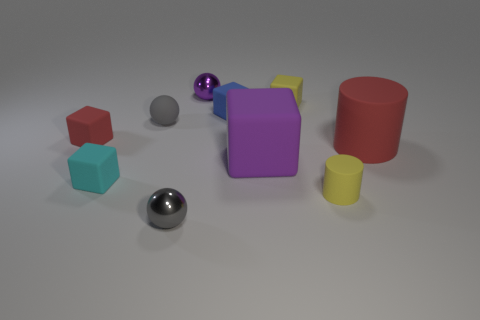The red thing that is on the left side of the gray rubber sphere has what shape?
Provide a succinct answer. Cube. The cylinder in front of the big cylinder behind the matte object that is in front of the tiny cyan block is what color?
Your answer should be very brief. Yellow. The purple object that is the same material as the small cylinder is what shape?
Your response must be concise. Cube. Is the number of large blue blocks less than the number of tiny gray rubber things?
Provide a succinct answer. Yes. Do the tiny cyan cube and the small cylinder have the same material?
Offer a terse response. Yes. How many other objects are the same color as the small rubber sphere?
Give a very brief answer. 1. Is the number of big purple rubber objects greater than the number of tiny yellow rubber things?
Offer a very short reply. No. Do the cyan matte block and the red matte object left of the purple shiny object have the same size?
Ensure brevity in your answer.  Yes. What color is the ball that is in front of the tiny yellow cylinder?
Your response must be concise. Gray. How many gray things are either small matte blocks or big blocks?
Your response must be concise. 0. 